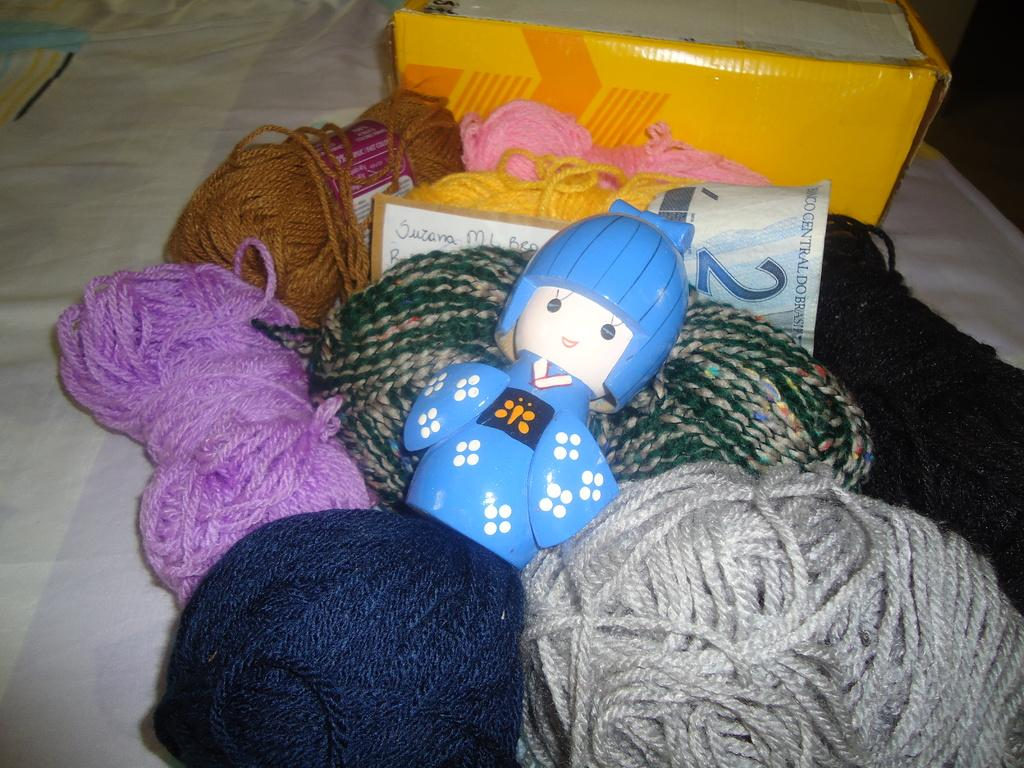What is located in the center of the image? There is wool, a toy, boxes, and a note in the center of the image. Can you describe the toy in the center of the image? Unfortunately, the facts provided do not give a detailed description of the toy. What type of containers are present in the center of the image? There are boxes in the center of the image. What is written on the note in the center of the image? The facts provided do not give information about the content of the note. What is at the bottom of the image? There is a bed at the bottom of the image. Can you see any ducks swimming in the lake in the image? There is no lake or ducks present in the image. What type of sweater is being knitted with the wool in the image? The facts provided do not mention a sweater or any knitting activity. 